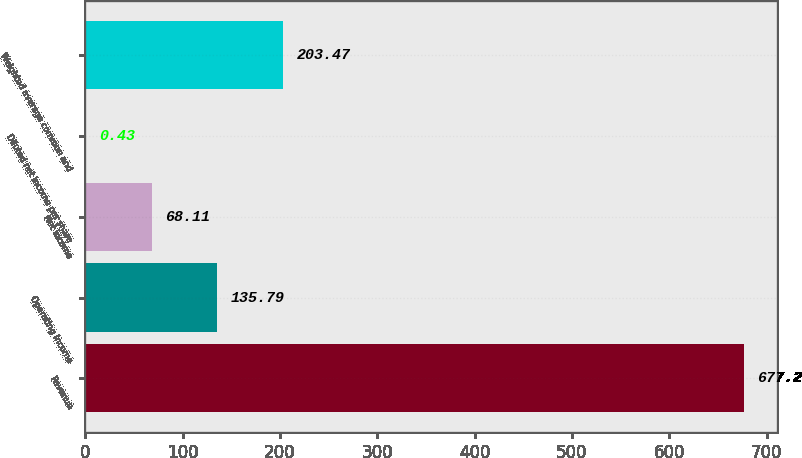<chart> <loc_0><loc_0><loc_500><loc_500><bar_chart><fcel>Revenue<fcel>Operating income<fcel>Net income<fcel>Diluted net income per share<fcel>Weighted average common and<nl><fcel>677.2<fcel>135.79<fcel>68.11<fcel>0.43<fcel>203.47<nl></chart> 